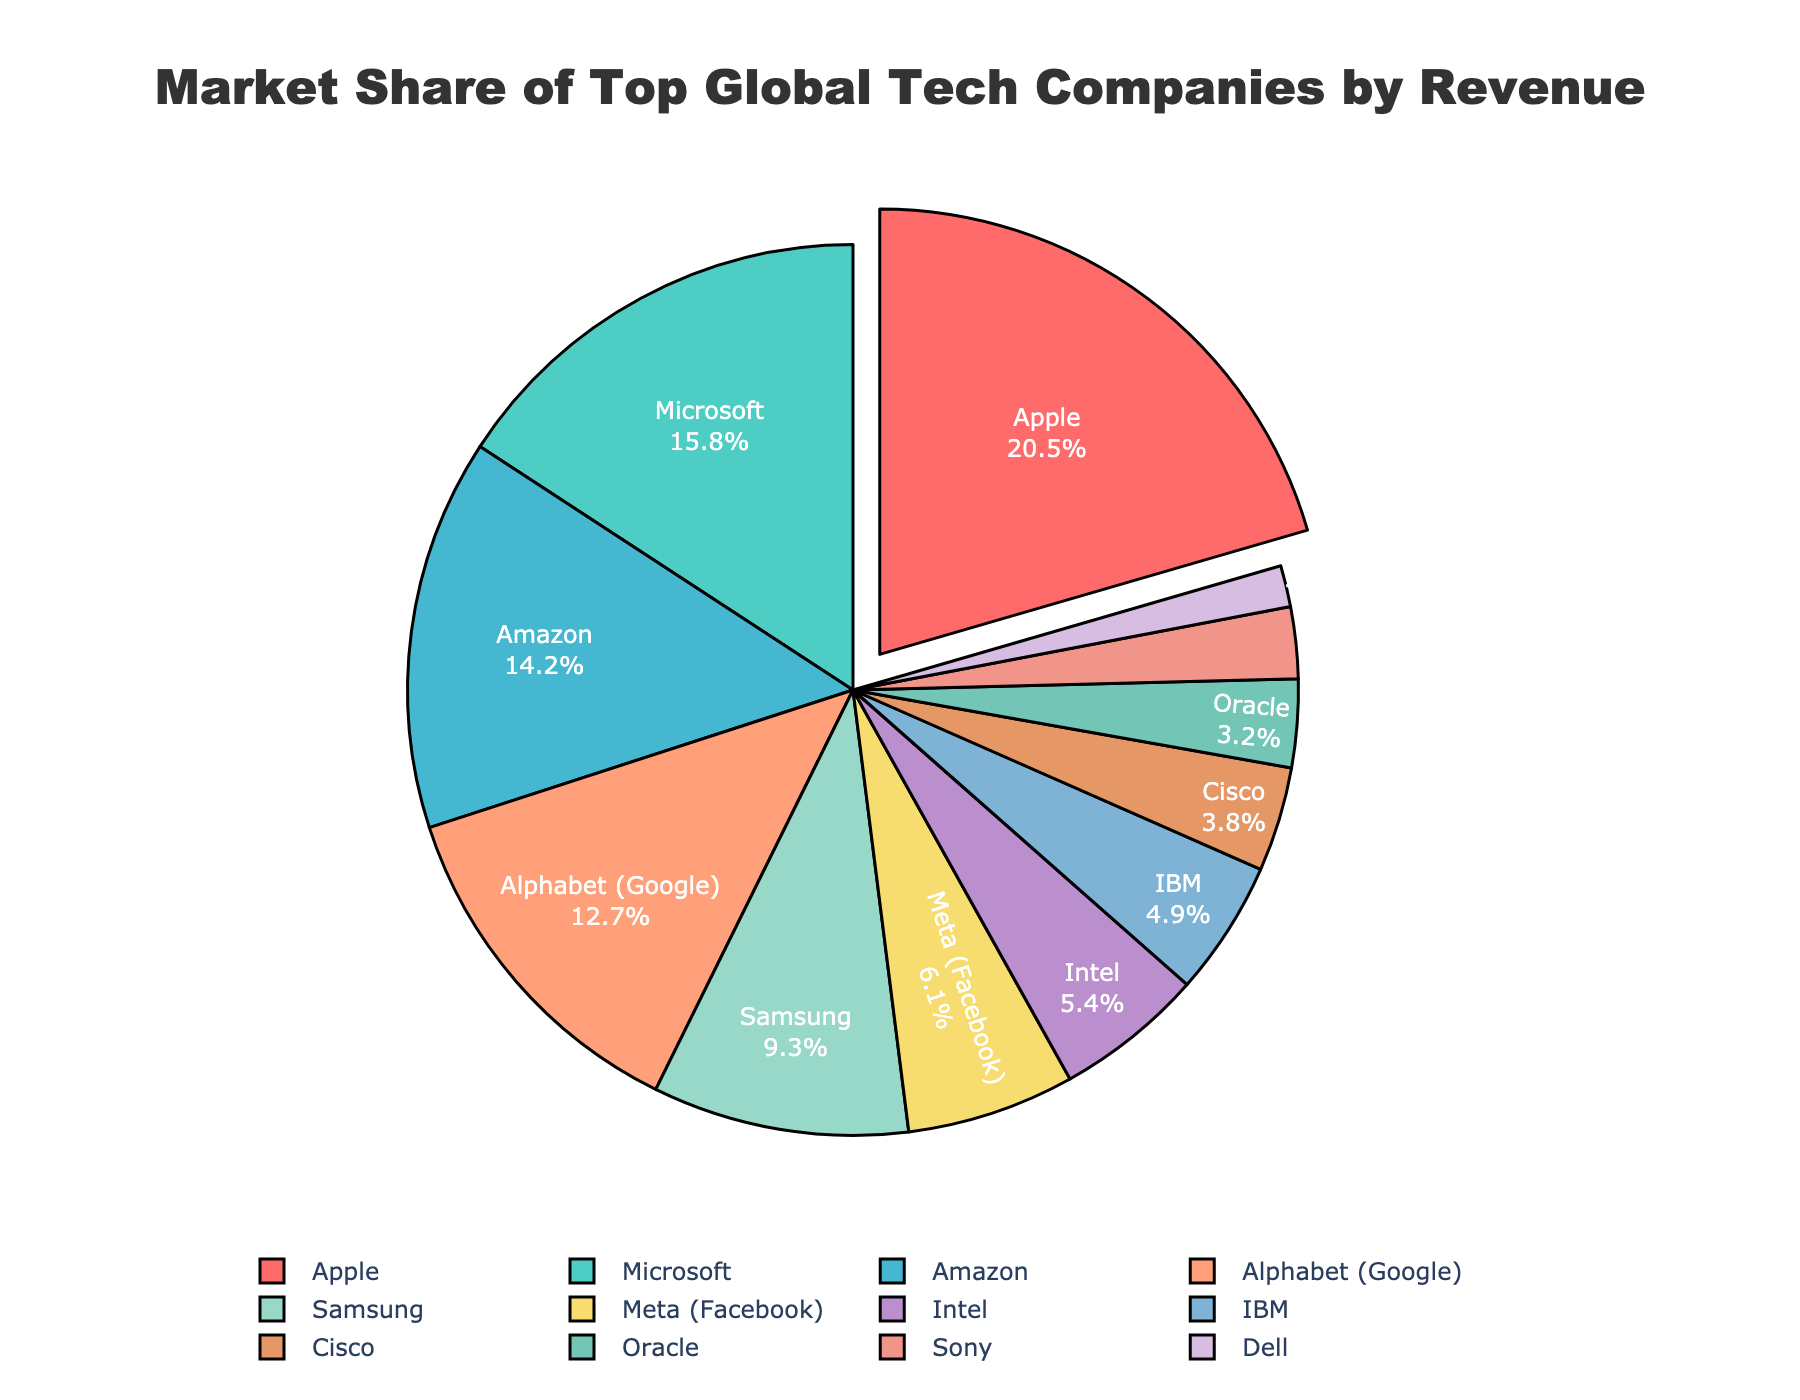What is the market share percentage of Intel? According to the pie chart, find Intel's segment and read the percentage value indicated. Intel's segment shows a market share of 5.4%.
Answer: 5.4% Which company has the highest market share and what is the percentage? Locate the segment with the largest size on the pie chart and check the label. Apple's segment is the largest, with a market share of 20.5%.
Answer: Apple, 20.5% What is the combined market share of Amazon and Alphabet (Google)? Locate the segments for Amazon and Alphabet (Google) and sum their percentages: Amazon (14.2%) + Alphabet (12.7%). 14.2% + 12.7% = 26.9%.
Answer: 26.9% Which companies have a market share less than 5%? Identify the segments with market shares below 5% and list the corresponding companies. The companies with less than 5% are Intel (5.4%), IBM (4.9%), Cisco (3.8%), Oracle (3.2%), Sony (2.6%), and Dell (1.5%).
Answer: IBM, Cisco, Oracle, Sony, Dell Compare the combined market share of Microsoft and Amazon to Apple's market share. Are they higher or lower? Sum Microsoft's and Amazon's market shares: Microsoft (15.8%) + Amazon (14.2%) = 30%. Compare this to Apple's market share of 20.5%. Microsoft's and Amazon's combined share (30%) is higher than Apple's (20.5%).
Answer: Higher Which segment is pulled out from the pie chart? Observe the pie chart to see which segment appears separated from the rest. The Apple segment is pulled out.
Answer: Apple What is the cumulative market share of companies with more than 10% share? Identify companies with more than 10% share (Apple, Microsoft, Amazon, Alphabet) and sum their percentages: 20.5% + 15.8% + 14.2% + 12.7%. 20.5% + 15.8% + 14.2% + 12.7% = 63.2%.
Answer: 63.2% If Samsung's market share increased by 2%, what would the new percentage be? Add 2% to Samsung's current market share of 9.3%. 9.3% + 2% = 11.3%.
Answer: 11.3% Is Meta's market share closer to Intel's or Cisco's? Compare Meta's market share (6.1%) with Intel's (5.4%) and Cisco’s (3.8%). The difference is 0.7% with Intel and 2.3% with Cisco. Hence, Meta's market share is closer to Intel's.
Answer: Intel's 